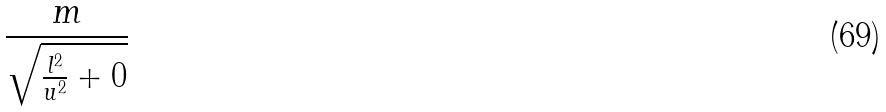Convert formula to latex. <formula><loc_0><loc_0><loc_500><loc_500>\frac { m } { \sqrt { \frac { l ^ { 2 } } { u ^ { 2 } } + 0 } }</formula> 